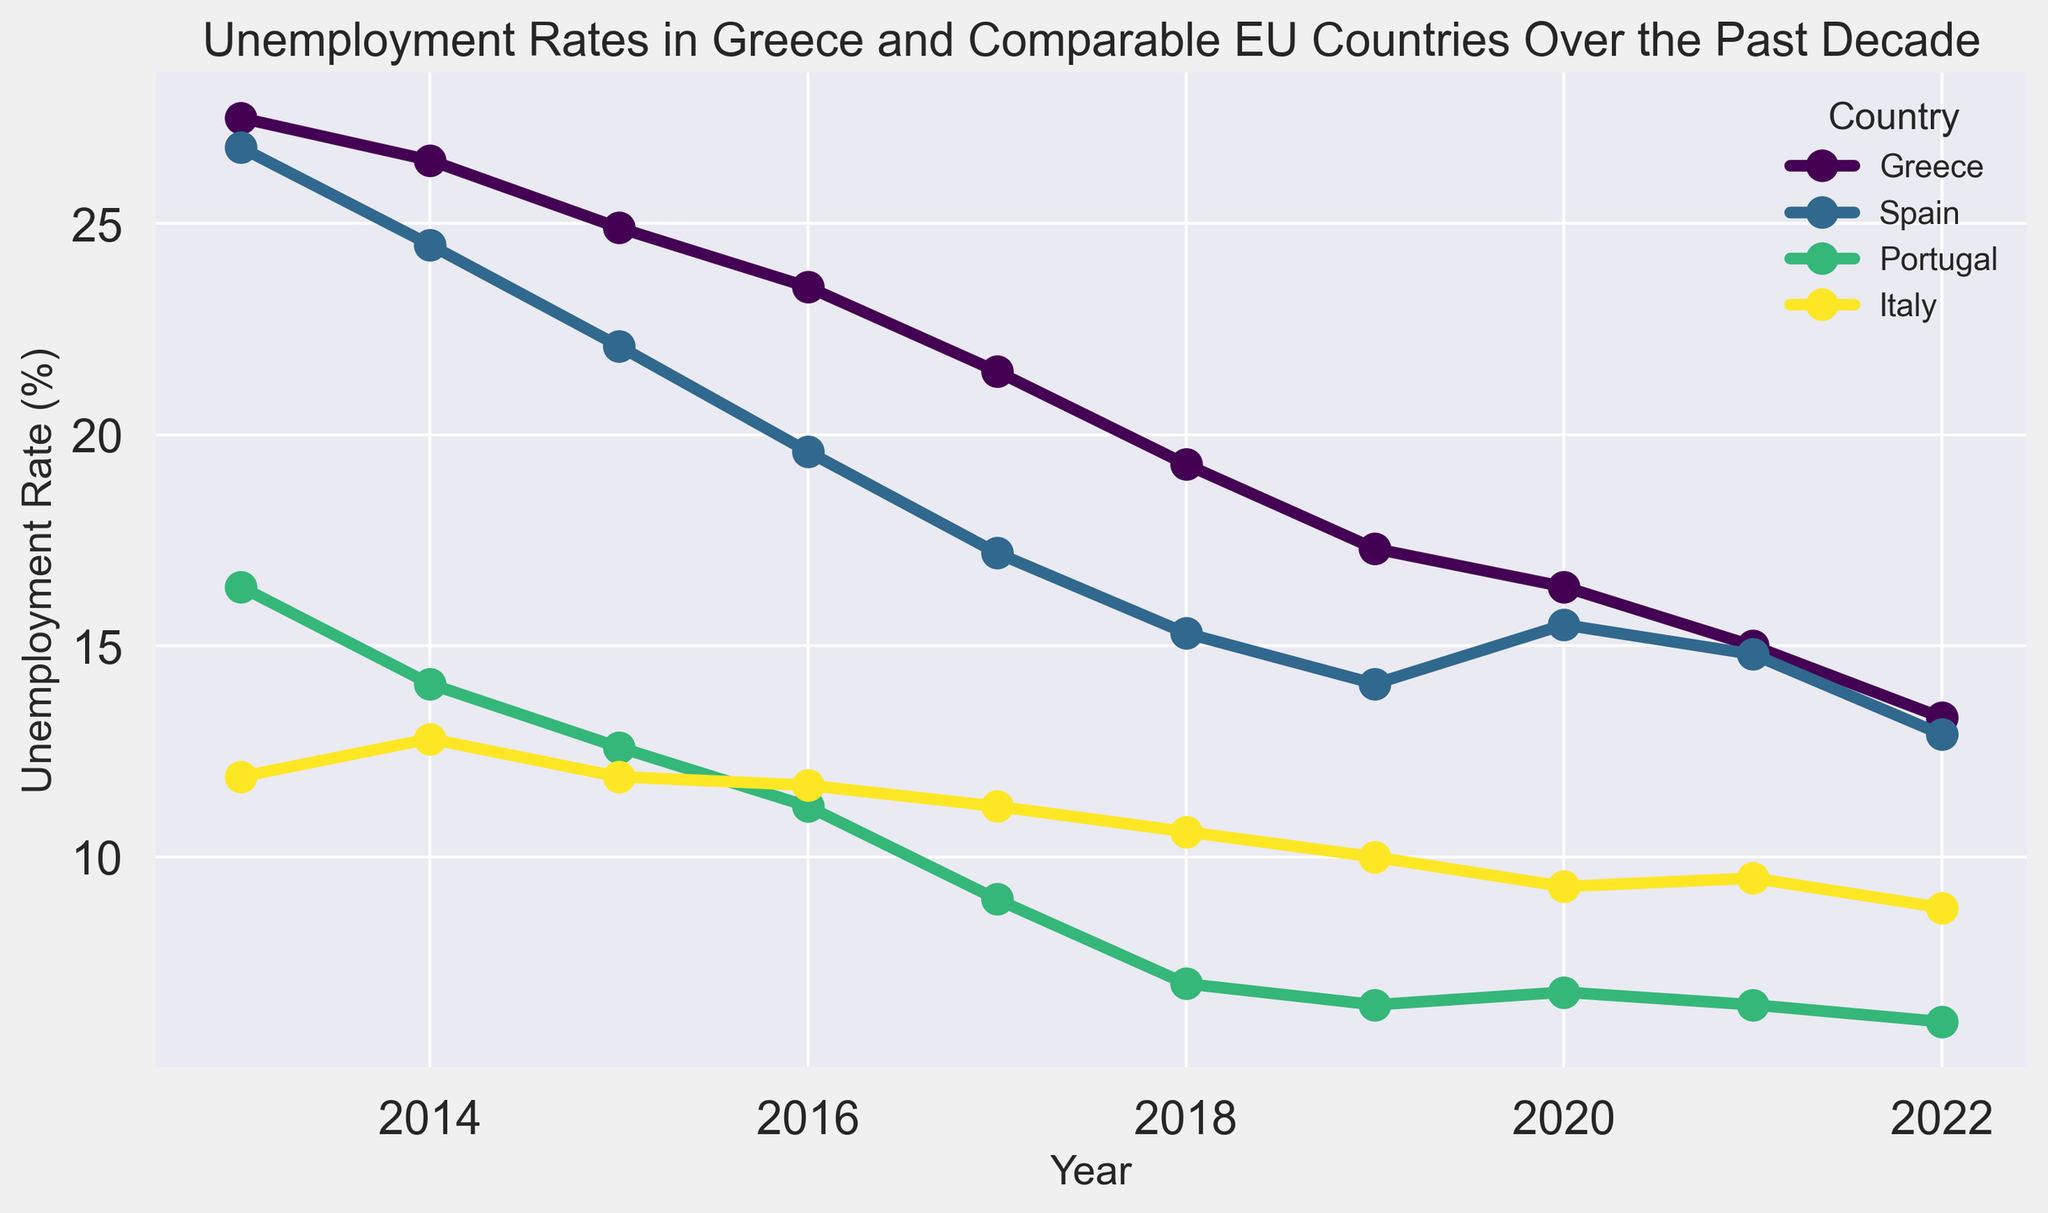What was the unemployment rate in Greece in 2013? Simply find the data point for Greece in the year 2013 on the graph.
Answer: 27.5% Which country had the highest unemployment rate in 2018 and what was it? Examine the plot for the year 2018 and identify which line reaches the highest point. That's Greece. The highest point on the Greece line represents the maximum unemployment rate.
Answer: Greece, 19.3% Did the unemployment rate in Spain decrease more significantly than in Greece between 2013 and 2022? Compare the difference in unemployment rates over the years for both countries. For Greece, subtract the 2022 value from the 2013 value (27.5 - 13.3 = 14.2). For Spain, do the same subtraction (26.8 - 12.9 = 13.9). Comparing these differences shows that Greece had a greater decrease.
Answer: No Compare the unemployment rate trends in Portugal and Italy. Which country showed a more consistent decrease over the decade? Evaluate the visual trend of the lines for Portugal and Italy from 2013 to 2022. Portugal shows a smoother and more consistent decline, whereas Italy has smaller and relatively more fluctuating decreases.
Answer: Portugal Which year did Greece experience the largest year-over-year decrease in unemployment rate, and what was the decrease? Inspect the plot and calculate the year-over-year changes for Greece. The largest drop is observed between 2021 (15.0%) and 2022 (13.3%). This results in a decrease of 1.7 percentage points.
Answer: 2022, 1.7% How did the unemployment rate in Italy change from 2014 to 2015? Locate the points on the graph for Italy in the years 2014 and 2015 to find their values (12.8% and 11.9%). Subtract to find the difference (12.8 - 11.9 = 0.9%).
Answer: Decreased by 0.9% Which country had the lowest unemployment rate in 2022 and what was it? Check the unemployment rates for each country in 2022. Portugal's line reaches the lowest point in this year.
Answer: Portugal, 6.1% Considering the entire period from 2013 to 2022, by how many percentage points did the unemployment rate in Greece decrease? Subtract the unemployment rate for Greece in 2022 from its rate in 2013 (27.5 - 13.3 = 14.2).
Answer: 14.2 percentage points 